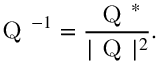<formula> <loc_0><loc_0><loc_500><loc_500>{ Q } ^ { - 1 } = \frac { { Q } ^ { * } } { | { Q } | ^ { 2 } } .</formula> 